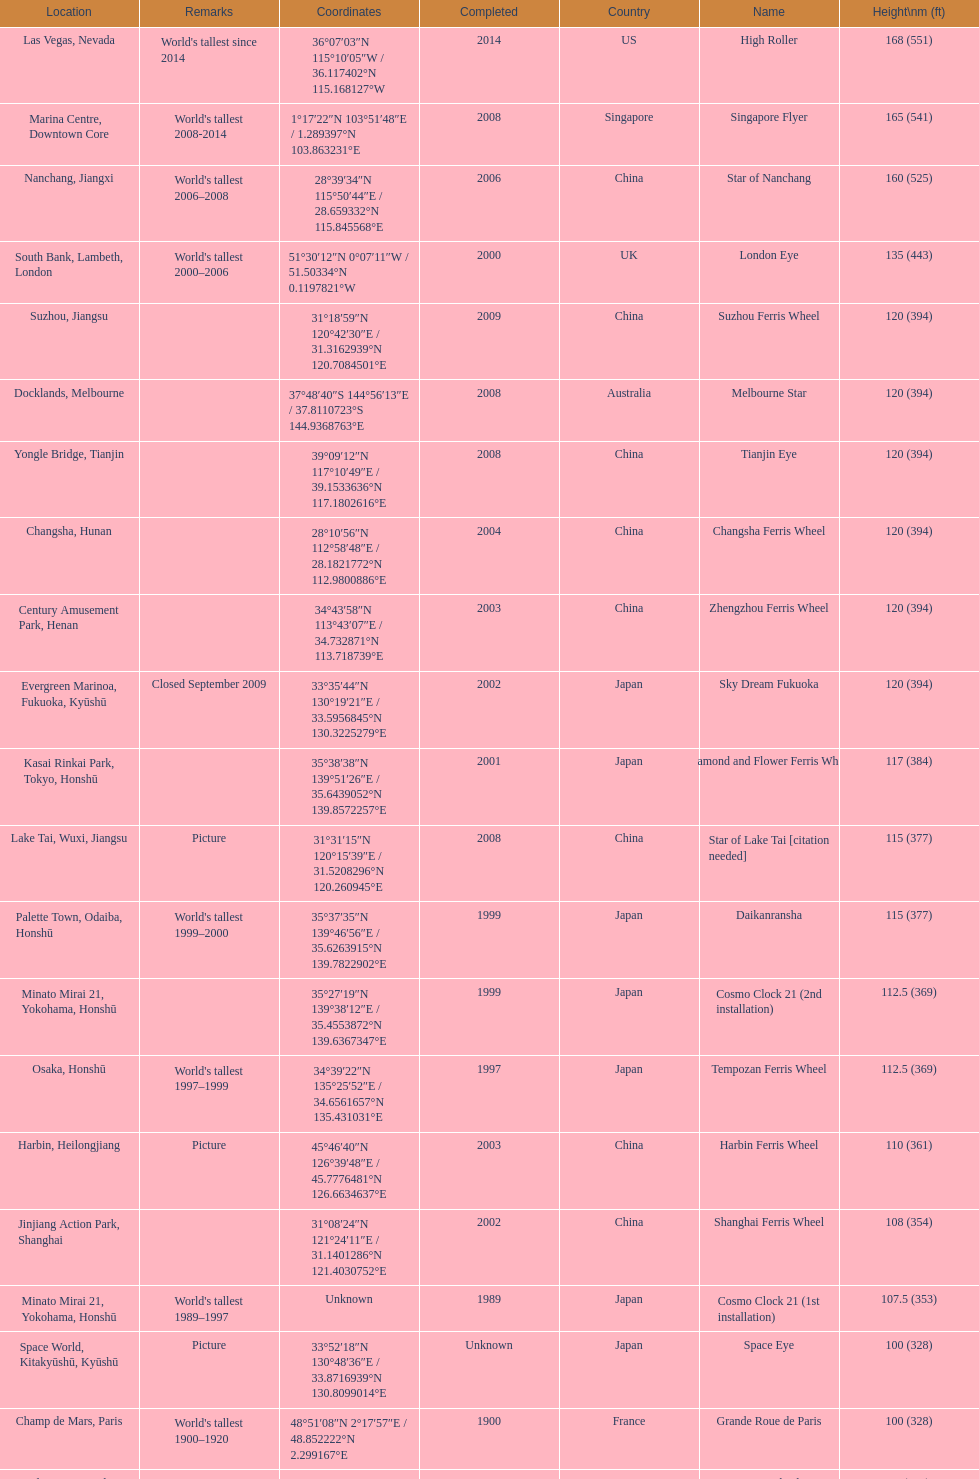Which of the following roller coasters is the oldest: star of lake tai, star of nanchang, melbourne star Star of Nanchang. 